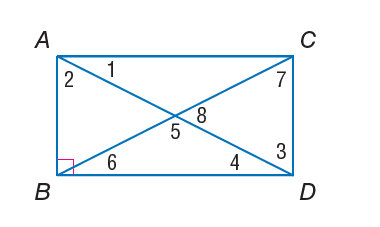Answer the mathemtical geometry problem and directly provide the correct option letter.
Question: Quadrilateral A B C D is a rectangle. m \angle 2 = 40. Find m \angle 5.
Choices: A: 30 B: 40 C: 50 D: 80 D 